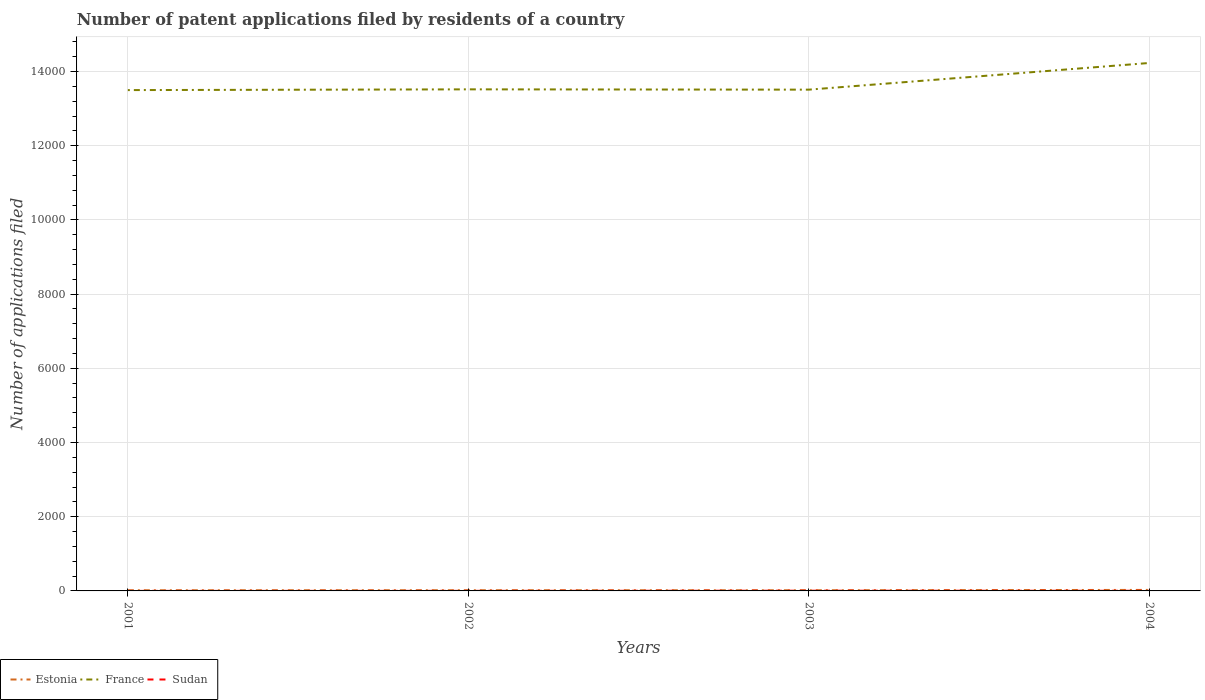What is the total number of applications filed in Sudan in the graph?
Provide a short and direct response. -2. What is the difference between the highest and the second highest number of applications filed in Sudan?
Provide a succinct answer. 5. Is the number of applications filed in Sudan strictly greater than the number of applications filed in Estonia over the years?
Offer a very short reply. Yes. How many lines are there?
Offer a very short reply. 3. What is the difference between two consecutive major ticks on the Y-axis?
Your response must be concise. 2000. Are the values on the major ticks of Y-axis written in scientific E-notation?
Offer a terse response. No. Does the graph contain grids?
Keep it short and to the point. Yes. Where does the legend appear in the graph?
Your answer should be very brief. Bottom left. How many legend labels are there?
Ensure brevity in your answer.  3. What is the title of the graph?
Offer a terse response. Number of patent applications filed by residents of a country. Does "Honduras" appear as one of the legend labels in the graph?
Your answer should be compact. No. What is the label or title of the Y-axis?
Your answer should be very brief. Number of applications filed. What is the Number of applications filed in France in 2001?
Offer a terse response. 1.35e+04. What is the Number of applications filed of Sudan in 2001?
Ensure brevity in your answer.  1. What is the Number of applications filed in Estonia in 2002?
Ensure brevity in your answer.  19. What is the Number of applications filed in France in 2002?
Give a very brief answer. 1.35e+04. What is the Number of applications filed in France in 2003?
Keep it short and to the point. 1.35e+04. What is the Number of applications filed in Estonia in 2004?
Your answer should be compact. 27. What is the Number of applications filed in France in 2004?
Make the answer very short. 1.42e+04. What is the Number of applications filed of Sudan in 2004?
Ensure brevity in your answer.  4. Across all years, what is the maximum Number of applications filed of Estonia?
Your response must be concise. 27. Across all years, what is the maximum Number of applications filed in France?
Your answer should be compact. 1.42e+04. Across all years, what is the minimum Number of applications filed in Estonia?
Offer a very short reply. 18. Across all years, what is the minimum Number of applications filed in France?
Your response must be concise. 1.35e+04. What is the total Number of applications filed in Estonia in the graph?
Provide a short and direct response. 82. What is the total Number of applications filed in France in the graph?
Give a very brief answer. 5.48e+04. What is the difference between the Number of applications filed of Estonia in 2001 and that in 2002?
Your answer should be compact. -1. What is the difference between the Number of applications filed of Estonia in 2001 and that in 2003?
Give a very brief answer. 0. What is the difference between the Number of applications filed of France in 2001 and that in 2003?
Your response must be concise. -12. What is the difference between the Number of applications filed of France in 2001 and that in 2004?
Give a very brief answer. -731. What is the difference between the Number of applications filed of Sudan in 2001 and that in 2004?
Offer a very short reply. -3. What is the difference between the Number of applications filed of Estonia in 2002 and that in 2003?
Your response must be concise. 1. What is the difference between the Number of applications filed in Sudan in 2002 and that in 2003?
Keep it short and to the point. -4. What is the difference between the Number of applications filed of Estonia in 2002 and that in 2004?
Offer a very short reply. -8. What is the difference between the Number of applications filed of France in 2002 and that in 2004?
Ensure brevity in your answer.  -711. What is the difference between the Number of applications filed in Sudan in 2002 and that in 2004?
Keep it short and to the point. -2. What is the difference between the Number of applications filed in Estonia in 2003 and that in 2004?
Offer a terse response. -9. What is the difference between the Number of applications filed of France in 2003 and that in 2004?
Offer a terse response. -719. What is the difference between the Number of applications filed in Sudan in 2003 and that in 2004?
Make the answer very short. 2. What is the difference between the Number of applications filed in Estonia in 2001 and the Number of applications filed in France in 2002?
Keep it short and to the point. -1.35e+04. What is the difference between the Number of applications filed of Estonia in 2001 and the Number of applications filed of Sudan in 2002?
Offer a terse response. 16. What is the difference between the Number of applications filed of France in 2001 and the Number of applications filed of Sudan in 2002?
Your answer should be compact. 1.35e+04. What is the difference between the Number of applications filed in Estonia in 2001 and the Number of applications filed in France in 2003?
Keep it short and to the point. -1.35e+04. What is the difference between the Number of applications filed in France in 2001 and the Number of applications filed in Sudan in 2003?
Offer a very short reply. 1.35e+04. What is the difference between the Number of applications filed of Estonia in 2001 and the Number of applications filed of France in 2004?
Your response must be concise. -1.42e+04. What is the difference between the Number of applications filed of Estonia in 2001 and the Number of applications filed of Sudan in 2004?
Make the answer very short. 14. What is the difference between the Number of applications filed of France in 2001 and the Number of applications filed of Sudan in 2004?
Provide a succinct answer. 1.35e+04. What is the difference between the Number of applications filed in Estonia in 2002 and the Number of applications filed in France in 2003?
Ensure brevity in your answer.  -1.35e+04. What is the difference between the Number of applications filed of France in 2002 and the Number of applications filed of Sudan in 2003?
Your answer should be very brief. 1.35e+04. What is the difference between the Number of applications filed in Estonia in 2002 and the Number of applications filed in France in 2004?
Ensure brevity in your answer.  -1.42e+04. What is the difference between the Number of applications filed of Estonia in 2002 and the Number of applications filed of Sudan in 2004?
Keep it short and to the point. 15. What is the difference between the Number of applications filed in France in 2002 and the Number of applications filed in Sudan in 2004?
Make the answer very short. 1.35e+04. What is the difference between the Number of applications filed of Estonia in 2003 and the Number of applications filed of France in 2004?
Make the answer very short. -1.42e+04. What is the difference between the Number of applications filed of France in 2003 and the Number of applications filed of Sudan in 2004?
Your answer should be very brief. 1.35e+04. What is the average Number of applications filed in France per year?
Keep it short and to the point. 1.37e+04. In the year 2001, what is the difference between the Number of applications filed in Estonia and Number of applications filed in France?
Give a very brief answer. -1.35e+04. In the year 2001, what is the difference between the Number of applications filed of Estonia and Number of applications filed of Sudan?
Offer a terse response. 17. In the year 2001, what is the difference between the Number of applications filed in France and Number of applications filed in Sudan?
Keep it short and to the point. 1.35e+04. In the year 2002, what is the difference between the Number of applications filed of Estonia and Number of applications filed of France?
Give a very brief answer. -1.35e+04. In the year 2002, what is the difference between the Number of applications filed of France and Number of applications filed of Sudan?
Your response must be concise. 1.35e+04. In the year 2003, what is the difference between the Number of applications filed of Estonia and Number of applications filed of France?
Provide a succinct answer. -1.35e+04. In the year 2003, what is the difference between the Number of applications filed in France and Number of applications filed in Sudan?
Your answer should be very brief. 1.35e+04. In the year 2004, what is the difference between the Number of applications filed of Estonia and Number of applications filed of France?
Keep it short and to the point. -1.42e+04. In the year 2004, what is the difference between the Number of applications filed in France and Number of applications filed in Sudan?
Your answer should be very brief. 1.42e+04. What is the ratio of the Number of applications filed of France in 2001 to that in 2002?
Offer a very short reply. 1. What is the ratio of the Number of applications filed in Estonia in 2001 to that in 2004?
Ensure brevity in your answer.  0.67. What is the ratio of the Number of applications filed in France in 2001 to that in 2004?
Offer a very short reply. 0.95. What is the ratio of the Number of applications filed of Estonia in 2002 to that in 2003?
Keep it short and to the point. 1.06. What is the ratio of the Number of applications filed in France in 2002 to that in 2003?
Your answer should be very brief. 1. What is the ratio of the Number of applications filed of Estonia in 2002 to that in 2004?
Your answer should be very brief. 0.7. What is the ratio of the Number of applications filed of France in 2002 to that in 2004?
Ensure brevity in your answer.  0.95. What is the ratio of the Number of applications filed in Sudan in 2002 to that in 2004?
Provide a short and direct response. 0.5. What is the ratio of the Number of applications filed in France in 2003 to that in 2004?
Make the answer very short. 0.95. What is the ratio of the Number of applications filed in Sudan in 2003 to that in 2004?
Keep it short and to the point. 1.5. What is the difference between the highest and the second highest Number of applications filed in Estonia?
Provide a succinct answer. 8. What is the difference between the highest and the second highest Number of applications filed in France?
Provide a succinct answer. 711. What is the difference between the highest and the lowest Number of applications filed of France?
Make the answer very short. 731. What is the difference between the highest and the lowest Number of applications filed of Sudan?
Provide a succinct answer. 5. 